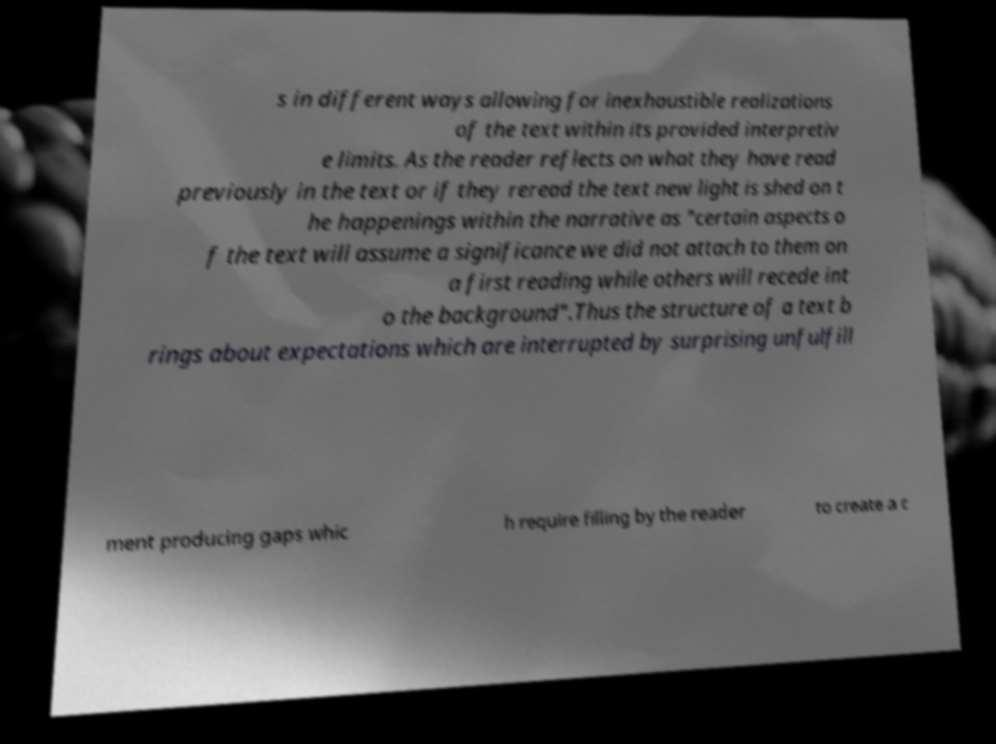I need the written content from this picture converted into text. Can you do that? s in different ways allowing for inexhaustible realizations of the text within its provided interpretiv e limits. As the reader reflects on what they have read previously in the text or if they reread the text new light is shed on t he happenings within the narrative as "certain aspects o f the text will assume a significance we did not attach to them on a first reading while others will recede int o the background".Thus the structure of a text b rings about expectations which are interrupted by surprising unfulfill ment producing gaps whic h require filling by the reader to create a c 